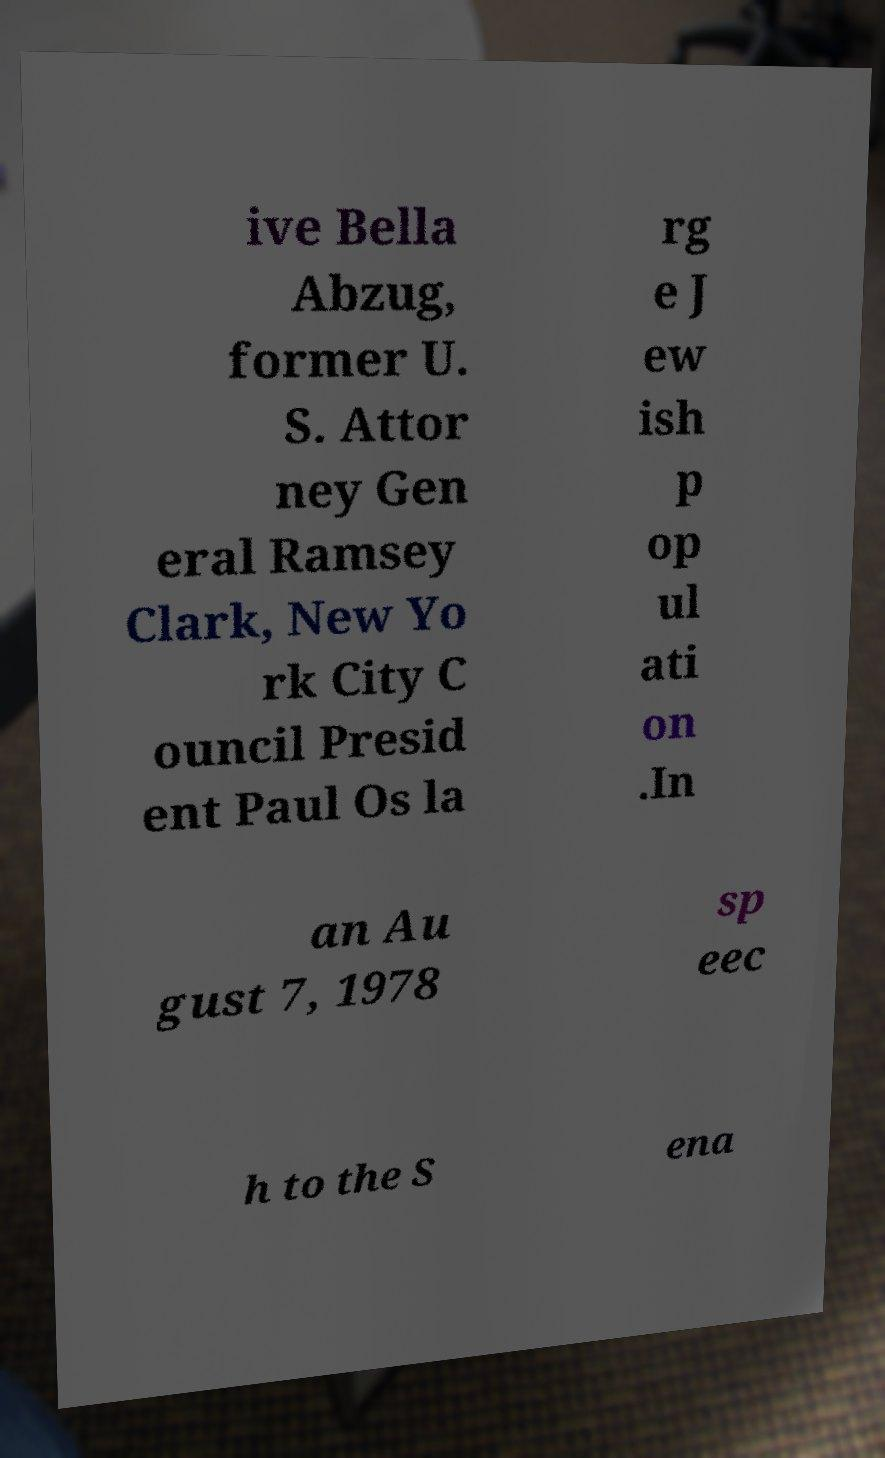Please identify and transcribe the text found in this image. ive Bella Abzug, former U. S. Attor ney Gen eral Ramsey Clark, New Yo rk City C ouncil Presid ent Paul Os la rg e J ew ish p op ul ati on .In an Au gust 7, 1978 sp eec h to the S ena 